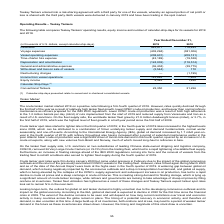According to Teekay Corporation's financial document, What led to the increase in Equity income in 2019? Based on the financial document, the answer is primarily due to higher earnings recognized in 2019 from the High-Q Investment Ltd. joint venture as a result of higher spot rates earned in 2019.. Also, can you calculate: What is the change in Revenues from, 2019 to 2018? Based on the calculation: 943,917-776,493, the result is 167424 (in thousands). This is based on the information: "Revenues 943,917 776,493 Revenues 943,917 776,493..." The key data points involved are: 776,493, 943,917. Also, can you calculate: What is the change in Voyage expenses from, 2019 to 2018? Based on the calculation: 402,294-381,306, the result is 20988 (in thousands). This is based on the information: "Voyage expenses (402,294) (381,306) Voyage expenses (402,294) (381,306)..." The key data points involved are: 381,306, 402,294. Additionally, In which year was revenue less than 800,000 thousands? According to the financial document, 2018. The relevant text states: "of U.S. dollars, except calendar-ship-days) 2019 2018..." Also, What is the value of Conventional Tankers in 2019? According to the financial document, 22,350 (in thousands). The relevant text states: "Conventional Tankers 22,350 21,226..." Also, What is the value of Conventional Tankers in 2018? According to the financial document, 21,226 (in thousands). The relevant text states: "Conventional Tankers 22,350 21,226..." 